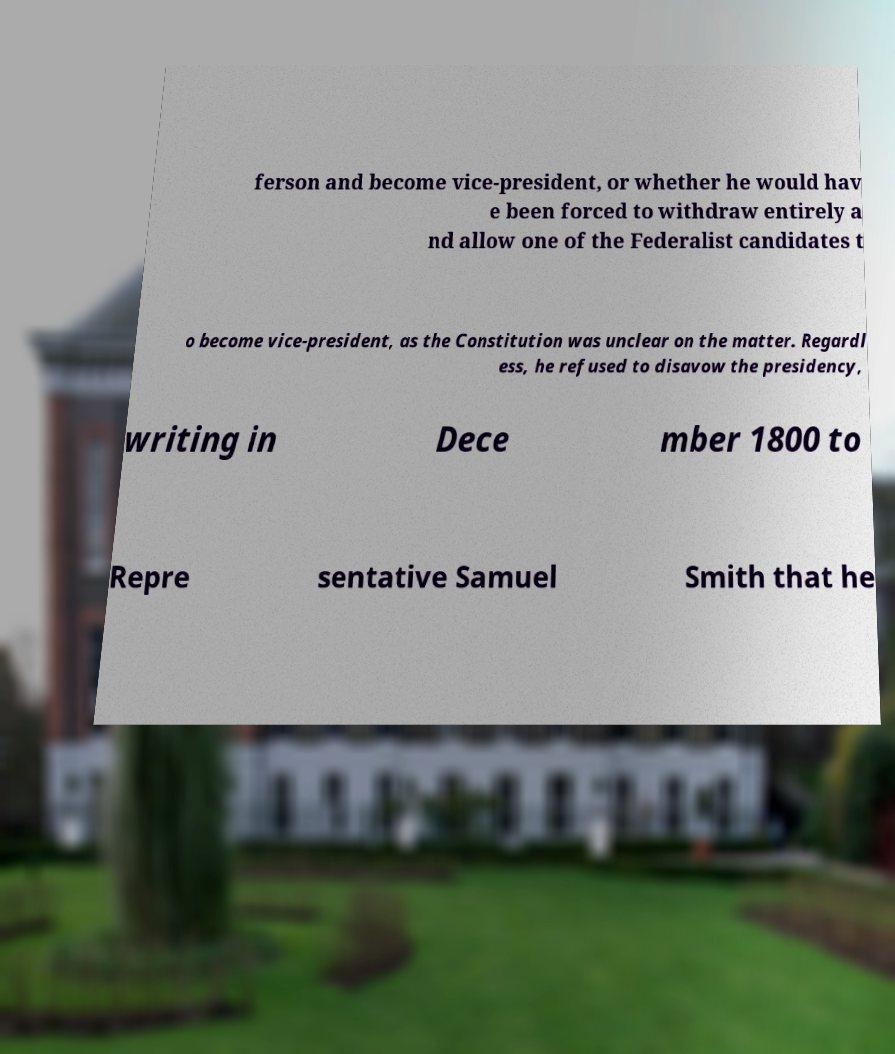Please read and relay the text visible in this image. What does it say? ferson and become vice-president, or whether he would hav e been forced to withdraw entirely a nd allow one of the Federalist candidates t o become vice-president, as the Constitution was unclear on the matter. Regardl ess, he refused to disavow the presidency, writing in Dece mber 1800 to Repre sentative Samuel Smith that he 